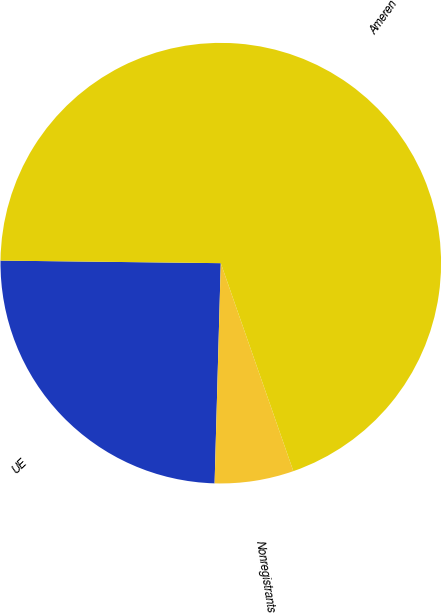Convert chart. <chart><loc_0><loc_0><loc_500><loc_500><pie_chart><fcel>UE<fcel>Nonregistrants<fcel>Ameren<nl><fcel>24.74%<fcel>5.79%<fcel>69.47%<nl></chart> 